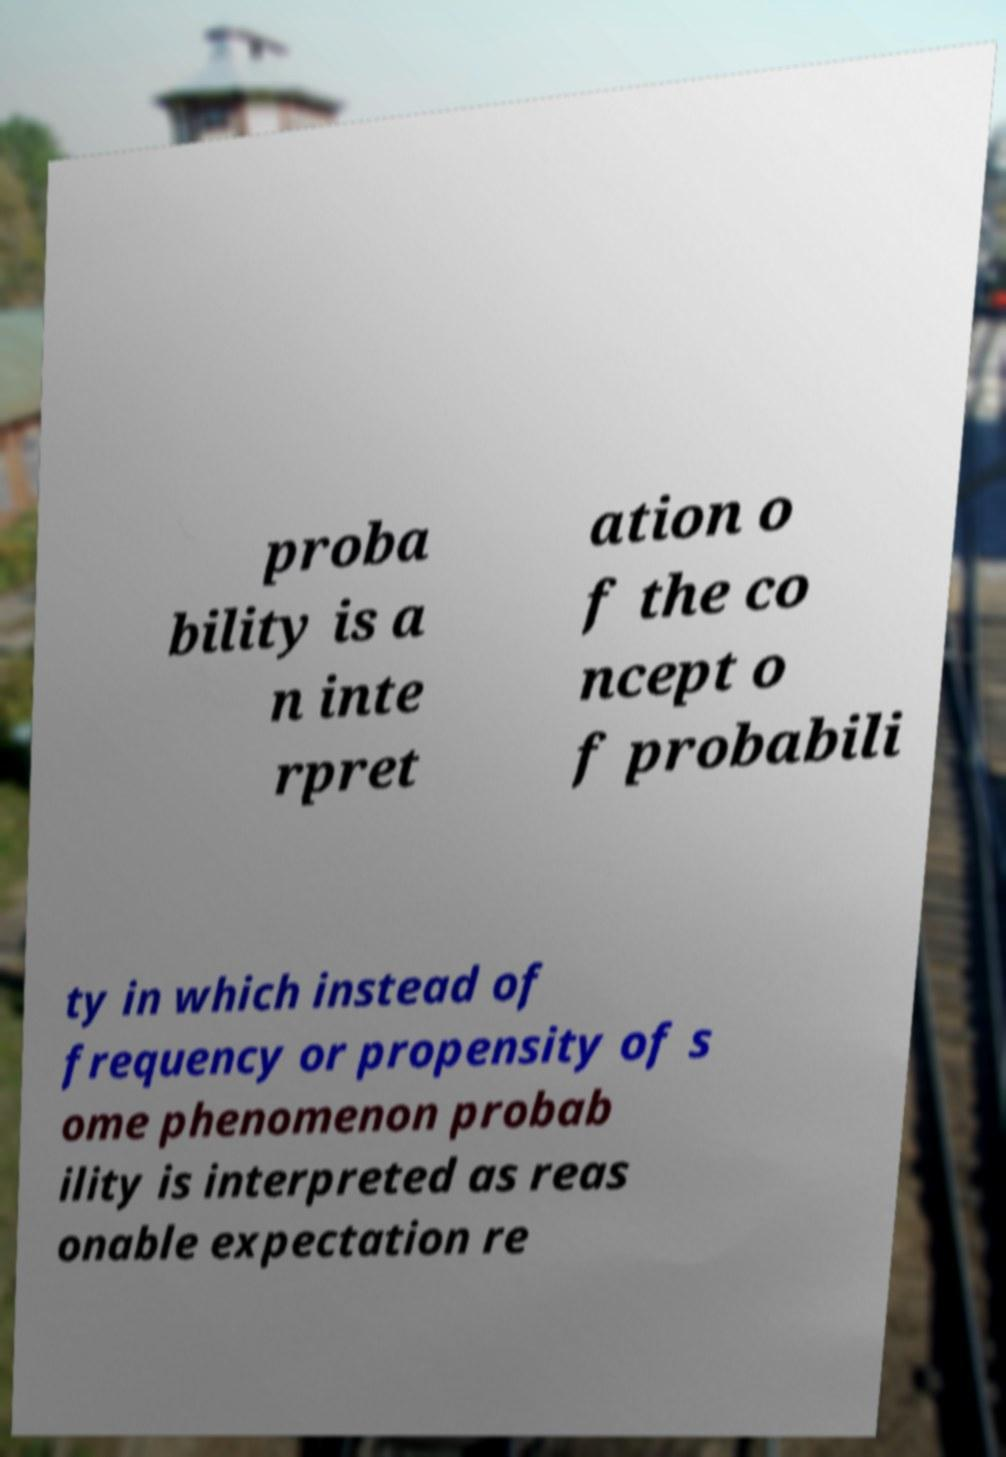Can you read and provide the text displayed in the image?This photo seems to have some interesting text. Can you extract and type it out for me? proba bility is a n inte rpret ation o f the co ncept o f probabili ty in which instead of frequency or propensity of s ome phenomenon probab ility is interpreted as reas onable expectation re 